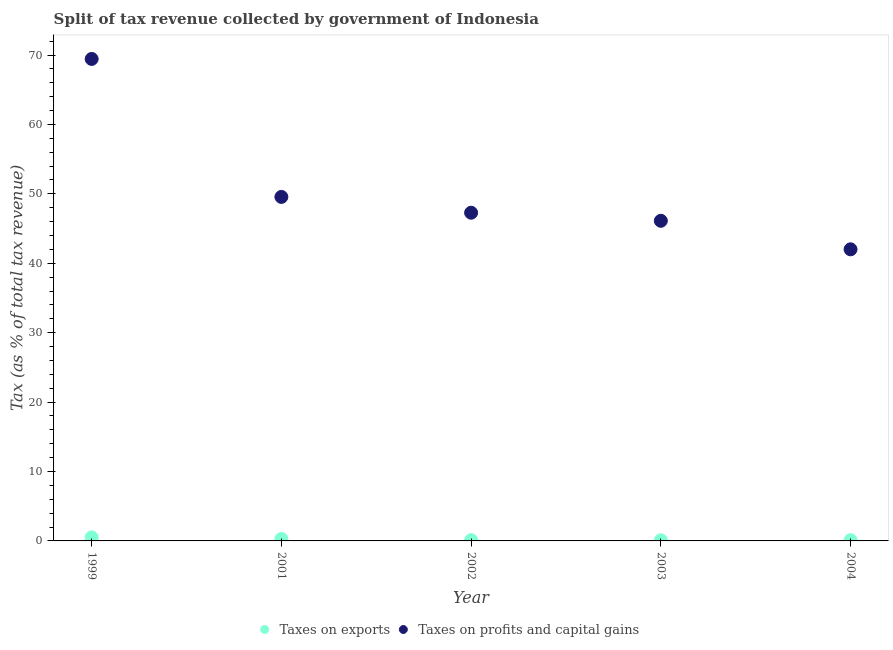How many different coloured dotlines are there?
Provide a succinct answer. 2. Is the number of dotlines equal to the number of legend labels?
Offer a terse response. Yes. What is the percentage of revenue obtained from taxes on profits and capital gains in 2003?
Provide a short and direct response. 46.12. Across all years, what is the maximum percentage of revenue obtained from taxes on profits and capital gains?
Your answer should be compact. 69.43. Across all years, what is the minimum percentage of revenue obtained from taxes on profits and capital gains?
Make the answer very short. 42.01. What is the total percentage of revenue obtained from taxes on profits and capital gains in the graph?
Make the answer very short. 254.39. What is the difference between the percentage of revenue obtained from taxes on exports in 1999 and that in 2002?
Offer a very short reply. 0.4. What is the difference between the percentage of revenue obtained from taxes on exports in 2002 and the percentage of revenue obtained from taxes on profits and capital gains in 2004?
Ensure brevity in your answer.  -41.9. What is the average percentage of revenue obtained from taxes on exports per year?
Keep it short and to the point. 0.22. In the year 2001, what is the difference between the percentage of revenue obtained from taxes on exports and percentage of revenue obtained from taxes on profits and capital gains?
Ensure brevity in your answer.  -49.27. What is the ratio of the percentage of revenue obtained from taxes on exports in 2001 to that in 2002?
Keep it short and to the point. 2.65. Is the percentage of revenue obtained from taxes on profits and capital gains in 2003 less than that in 2004?
Your answer should be compact. No. Is the difference between the percentage of revenue obtained from taxes on exports in 1999 and 2004 greater than the difference between the percentage of revenue obtained from taxes on profits and capital gains in 1999 and 2004?
Make the answer very short. No. What is the difference between the highest and the second highest percentage of revenue obtained from taxes on profits and capital gains?
Offer a terse response. 19.88. What is the difference between the highest and the lowest percentage of revenue obtained from taxes on exports?
Provide a short and direct response. 0.41. In how many years, is the percentage of revenue obtained from taxes on exports greater than the average percentage of revenue obtained from taxes on exports taken over all years?
Your answer should be very brief. 2. Does the percentage of revenue obtained from taxes on profits and capital gains monotonically increase over the years?
Offer a terse response. No. How many years are there in the graph?
Keep it short and to the point. 5. Does the graph contain any zero values?
Ensure brevity in your answer.  No. Does the graph contain grids?
Your answer should be very brief. No. Where does the legend appear in the graph?
Your answer should be compact. Bottom center. How many legend labels are there?
Your answer should be very brief. 2. How are the legend labels stacked?
Your response must be concise. Horizontal. What is the title of the graph?
Ensure brevity in your answer.  Split of tax revenue collected by government of Indonesia. What is the label or title of the Y-axis?
Provide a succinct answer. Tax (as % of total tax revenue). What is the Tax (as % of total tax revenue) of Taxes on exports in 1999?
Keep it short and to the point. 0.5. What is the Tax (as % of total tax revenue) in Taxes on profits and capital gains in 1999?
Your answer should be very brief. 69.43. What is the Tax (as % of total tax revenue) of Taxes on exports in 2001?
Your answer should be very brief. 0.28. What is the Tax (as % of total tax revenue) of Taxes on profits and capital gains in 2001?
Make the answer very short. 49.56. What is the Tax (as % of total tax revenue) of Taxes on exports in 2002?
Make the answer very short. 0.11. What is the Tax (as % of total tax revenue) in Taxes on profits and capital gains in 2002?
Give a very brief answer. 47.28. What is the Tax (as % of total tax revenue) of Taxes on exports in 2003?
Provide a short and direct response. 0.09. What is the Tax (as % of total tax revenue) of Taxes on profits and capital gains in 2003?
Make the answer very short. 46.12. What is the Tax (as % of total tax revenue) of Taxes on exports in 2004?
Provide a succinct answer. 0.11. What is the Tax (as % of total tax revenue) of Taxes on profits and capital gains in 2004?
Offer a terse response. 42.01. Across all years, what is the maximum Tax (as % of total tax revenue) in Taxes on exports?
Provide a succinct answer. 0.5. Across all years, what is the maximum Tax (as % of total tax revenue) of Taxes on profits and capital gains?
Make the answer very short. 69.43. Across all years, what is the minimum Tax (as % of total tax revenue) in Taxes on exports?
Your response must be concise. 0.09. Across all years, what is the minimum Tax (as % of total tax revenue) in Taxes on profits and capital gains?
Offer a very short reply. 42.01. What is the total Tax (as % of total tax revenue) of Taxes on exports in the graph?
Make the answer very short. 1.09. What is the total Tax (as % of total tax revenue) in Taxes on profits and capital gains in the graph?
Make the answer very short. 254.39. What is the difference between the Tax (as % of total tax revenue) of Taxes on exports in 1999 and that in 2001?
Offer a very short reply. 0.22. What is the difference between the Tax (as % of total tax revenue) in Taxes on profits and capital gains in 1999 and that in 2001?
Keep it short and to the point. 19.88. What is the difference between the Tax (as % of total tax revenue) in Taxes on exports in 1999 and that in 2002?
Your answer should be very brief. 0.4. What is the difference between the Tax (as % of total tax revenue) in Taxes on profits and capital gains in 1999 and that in 2002?
Your response must be concise. 22.15. What is the difference between the Tax (as % of total tax revenue) of Taxes on exports in 1999 and that in 2003?
Provide a succinct answer. 0.41. What is the difference between the Tax (as % of total tax revenue) in Taxes on profits and capital gains in 1999 and that in 2003?
Offer a very short reply. 23.32. What is the difference between the Tax (as % of total tax revenue) of Taxes on exports in 1999 and that in 2004?
Make the answer very short. 0.4. What is the difference between the Tax (as % of total tax revenue) in Taxes on profits and capital gains in 1999 and that in 2004?
Provide a short and direct response. 27.42. What is the difference between the Tax (as % of total tax revenue) of Taxes on exports in 2001 and that in 2002?
Your response must be concise. 0.18. What is the difference between the Tax (as % of total tax revenue) of Taxes on profits and capital gains in 2001 and that in 2002?
Ensure brevity in your answer.  2.28. What is the difference between the Tax (as % of total tax revenue) of Taxes on exports in 2001 and that in 2003?
Provide a succinct answer. 0.19. What is the difference between the Tax (as % of total tax revenue) in Taxes on profits and capital gains in 2001 and that in 2003?
Offer a very short reply. 3.44. What is the difference between the Tax (as % of total tax revenue) of Taxes on exports in 2001 and that in 2004?
Offer a very short reply. 0.18. What is the difference between the Tax (as % of total tax revenue) in Taxes on profits and capital gains in 2001 and that in 2004?
Your response must be concise. 7.55. What is the difference between the Tax (as % of total tax revenue) in Taxes on exports in 2002 and that in 2003?
Make the answer very short. 0.02. What is the difference between the Tax (as % of total tax revenue) in Taxes on profits and capital gains in 2002 and that in 2003?
Provide a short and direct response. 1.16. What is the difference between the Tax (as % of total tax revenue) of Taxes on exports in 2002 and that in 2004?
Your answer should be compact. 0. What is the difference between the Tax (as % of total tax revenue) of Taxes on profits and capital gains in 2002 and that in 2004?
Your answer should be very brief. 5.27. What is the difference between the Tax (as % of total tax revenue) of Taxes on exports in 2003 and that in 2004?
Your answer should be compact. -0.01. What is the difference between the Tax (as % of total tax revenue) of Taxes on profits and capital gains in 2003 and that in 2004?
Your answer should be compact. 4.11. What is the difference between the Tax (as % of total tax revenue) in Taxes on exports in 1999 and the Tax (as % of total tax revenue) in Taxes on profits and capital gains in 2001?
Offer a very short reply. -49.05. What is the difference between the Tax (as % of total tax revenue) in Taxes on exports in 1999 and the Tax (as % of total tax revenue) in Taxes on profits and capital gains in 2002?
Provide a short and direct response. -46.78. What is the difference between the Tax (as % of total tax revenue) of Taxes on exports in 1999 and the Tax (as % of total tax revenue) of Taxes on profits and capital gains in 2003?
Provide a short and direct response. -45.61. What is the difference between the Tax (as % of total tax revenue) in Taxes on exports in 1999 and the Tax (as % of total tax revenue) in Taxes on profits and capital gains in 2004?
Your response must be concise. -41.5. What is the difference between the Tax (as % of total tax revenue) in Taxes on exports in 2001 and the Tax (as % of total tax revenue) in Taxes on profits and capital gains in 2002?
Provide a short and direct response. -47. What is the difference between the Tax (as % of total tax revenue) of Taxes on exports in 2001 and the Tax (as % of total tax revenue) of Taxes on profits and capital gains in 2003?
Offer a very short reply. -45.83. What is the difference between the Tax (as % of total tax revenue) of Taxes on exports in 2001 and the Tax (as % of total tax revenue) of Taxes on profits and capital gains in 2004?
Ensure brevity in your answer.  -41.72. What is the difference between the Tax (as % of total tax revenue) of Taxes on exports in 2002 and the Tax (as % of total tax revenue) of Taxes on profits and capital gains in 2003?
Your answer should be very brief. -46.01. What is the difference between the Tax (as % of total tax revenue) of Taxes on exports in 2002 and the Tax (as % of total tax revenue) of Taxes on profits and capital gains in 2004?
Offer a terse response. -41.9. What is the difference between the Tax (as % of total tax revenue) in Taxes on exports in 2003 and the Tax (as % of total tax revenue) in Taxes on profits and capital gains in 2004?
Provide a succinct answer. -41.92. What is the average Tax (as % of total tax revenue) of Taxes on exports per year?
Provide a short and direct response. 0.22. What is the average Tax (as % of total tax revenue) in Taxes on profits and capital gains per year?
Give a very brief answer. 50.88. In the year 1999, what is the difference between the Tax (as % of total tax revenue) in Taxes on exports and Tax (as % of total tax revenue) in Taxes on profits and capital gains?
Make the answer very short. -68.93. In the year 2001, what is the difference between the Tax (as % of total tax revenue) of Taxes on exports and Tax (as % of total tax revenue) of Taxes on profits and capital gains?
Provide a succinct answer. -49.27. In the year 2002, what is the difference between the Tax (as % of total tax revenue) in Taxes on exports and Tax (as % of total tax revenue) in Taxes on profits and capital gains?
Make the answer very short. -47.17. In the year 2003, what is the difference between the Tax (as % of total tax revenue) of Taxes on exports and Tax (as % of total tax revenue) of Taxes on profits and capital gains?
Your response must be concise. -46.02. In the year 2004, what is the difference between the Tax (as % of total tax revenue) in Taxes on exports and Tax (as % of total tax revenue) in Taxes on profits and capital gains?
Give a very brief answer. -41.9. What is the ratio of the Tax (as % of total tax revenue) in Taxes on exports in 1999 to that in 2001?
Give a very brief answer. 1.77. What is the ratio of the Tax (as % of total tax revenue) of Taxes on profits and capital gains in 1999 to that in 2001?
Your answer should be very brief. 1.4. What is the ratio of the Tax (as % of total tax revenue) in Taxes on exports in 1999 to that in 2002?
Ensure brevity in your answer.  4.7. What is the ratio of the Tax (as % of total tax revenue) of Taxes on profits and capital gains in 1999 to that in 2002?
Offer a terse response. 1.47. What is the ratio of the Tax (as % of total tax revenue) of Taxes on exports in 1999 to that in 2003?
Ensure brevity in your answer.  5.47. What is the ratio of the Tax (as % of total tax revenue) of Taxes on profits and capital gains in 1999 to that in 2003?
Give a very brief answer. 1.51. What is the ratio of the Tax (as % of total tax revenue) in Taxes on exports in 1999 to that in 2004?
Ensure brevity in your answer.  4.79. What is the ratio of the Tax (as % of total tax revenue) of Taxes on profits and capital gains in 1999 to that in 2004?
Provide a short and direct response. 1.65. What is the ratio of the Tax (as % of total tax revenue) of Taxes on exports in 2001 to that in 2002?
Give a very brief answer. 2.65. What is the ratio of the Tax (as % of total tax revenue) in Taxes on profits and capital gains in 2001 to that in 2002?
Provide a short and direct response. 1.05. What is the ratio of the Tax (as % of total tax revenue) in Taxes on exports in 2001 to that in 2003?
Provide a short and direct response. 3.09. What is the ratio of the Tax (as % of total tax revenue) of Taxes on profits and capital gains in 2001 to that in 2003?
Ensure brevity in your answer.  1.07. What is the ratio of the Tax (as % of total tax revenue) in Taxes on exports in 2001 to that in 2004?
Ensure brevity in your answer.  2.7. What is the ratio of the Tax (as % of total tax revenue) in Taxes on profits and capital gains in 2001 to that in 2004?
Ensure brevity in your answer.  1.18. What is the ratio of the Tax (as % of total tax revenue) of Taxes on exports in 2002 to that in 2003?
Keep it short and to the point. 1.16. What is the ratio of the Tax (as % of total tax revenue) of Taxes on profits and capital gains in 2002 to that in 2003?
Your response must be concise. 1.03. What is the ratio of the Tax (as % of total tax revenue) of Taxes on exports in 2002 to that in 2004?
Offer a very short reply. 1.02. What is the ratio of the Tax (as % of total tax revenue) of Taxes on profits and capital gains in 2002 to that in 2004?
Provide a short and direct response. 1.13. What is the ratio of the Tax (as % of total tax revenue) of Taxes on exports in 2003 to that in 2004?
Your answer should be compact. 0.88. What is the ratio of the Tax (as % of total tax revenue) of Taxes on profits and capital gains in 2003 to that in 2004?
Make the answer very short. 1.1. What is the difference between the highest and the second highest Tax (as % of total tax revenue) of Taxes on exports?
Give a very brief answer. 0.22. What is the difference between the highest and the second highest Tax (as % of total tax revenue) in Taxes on profits and capital gains?
Ensure brevity in your answer.  19.88. What is the difference between the highest and the lowest Tax (as % of total tax revenue) in Taxes on exports?
Make the answer very short. 0.41. What is the difference between the highest and the lowest Tax (as % of total tax revenue) in Taxes on profits and capital gains?
Your answer should be compact. 27.42. 